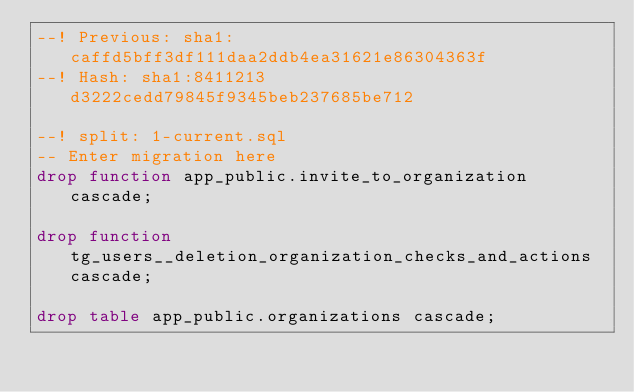<code> <loc_0><loc_0><loc_500><loc_500><_SQL_>--! Previous: sha1:caffd5bff3df111daa2ddb4ea31621e86304363f
--! Hash: sha1:8411213d3222cedd79845f9345beb237685be712

--! split: 1-current.sql
-- Enter migration here
drop function app_public.invite_to_organization cascade;

drop function tg_users__deletion_organization_checks_and_actions cascade;

drop table app_public.organizations cascade;
</code> 